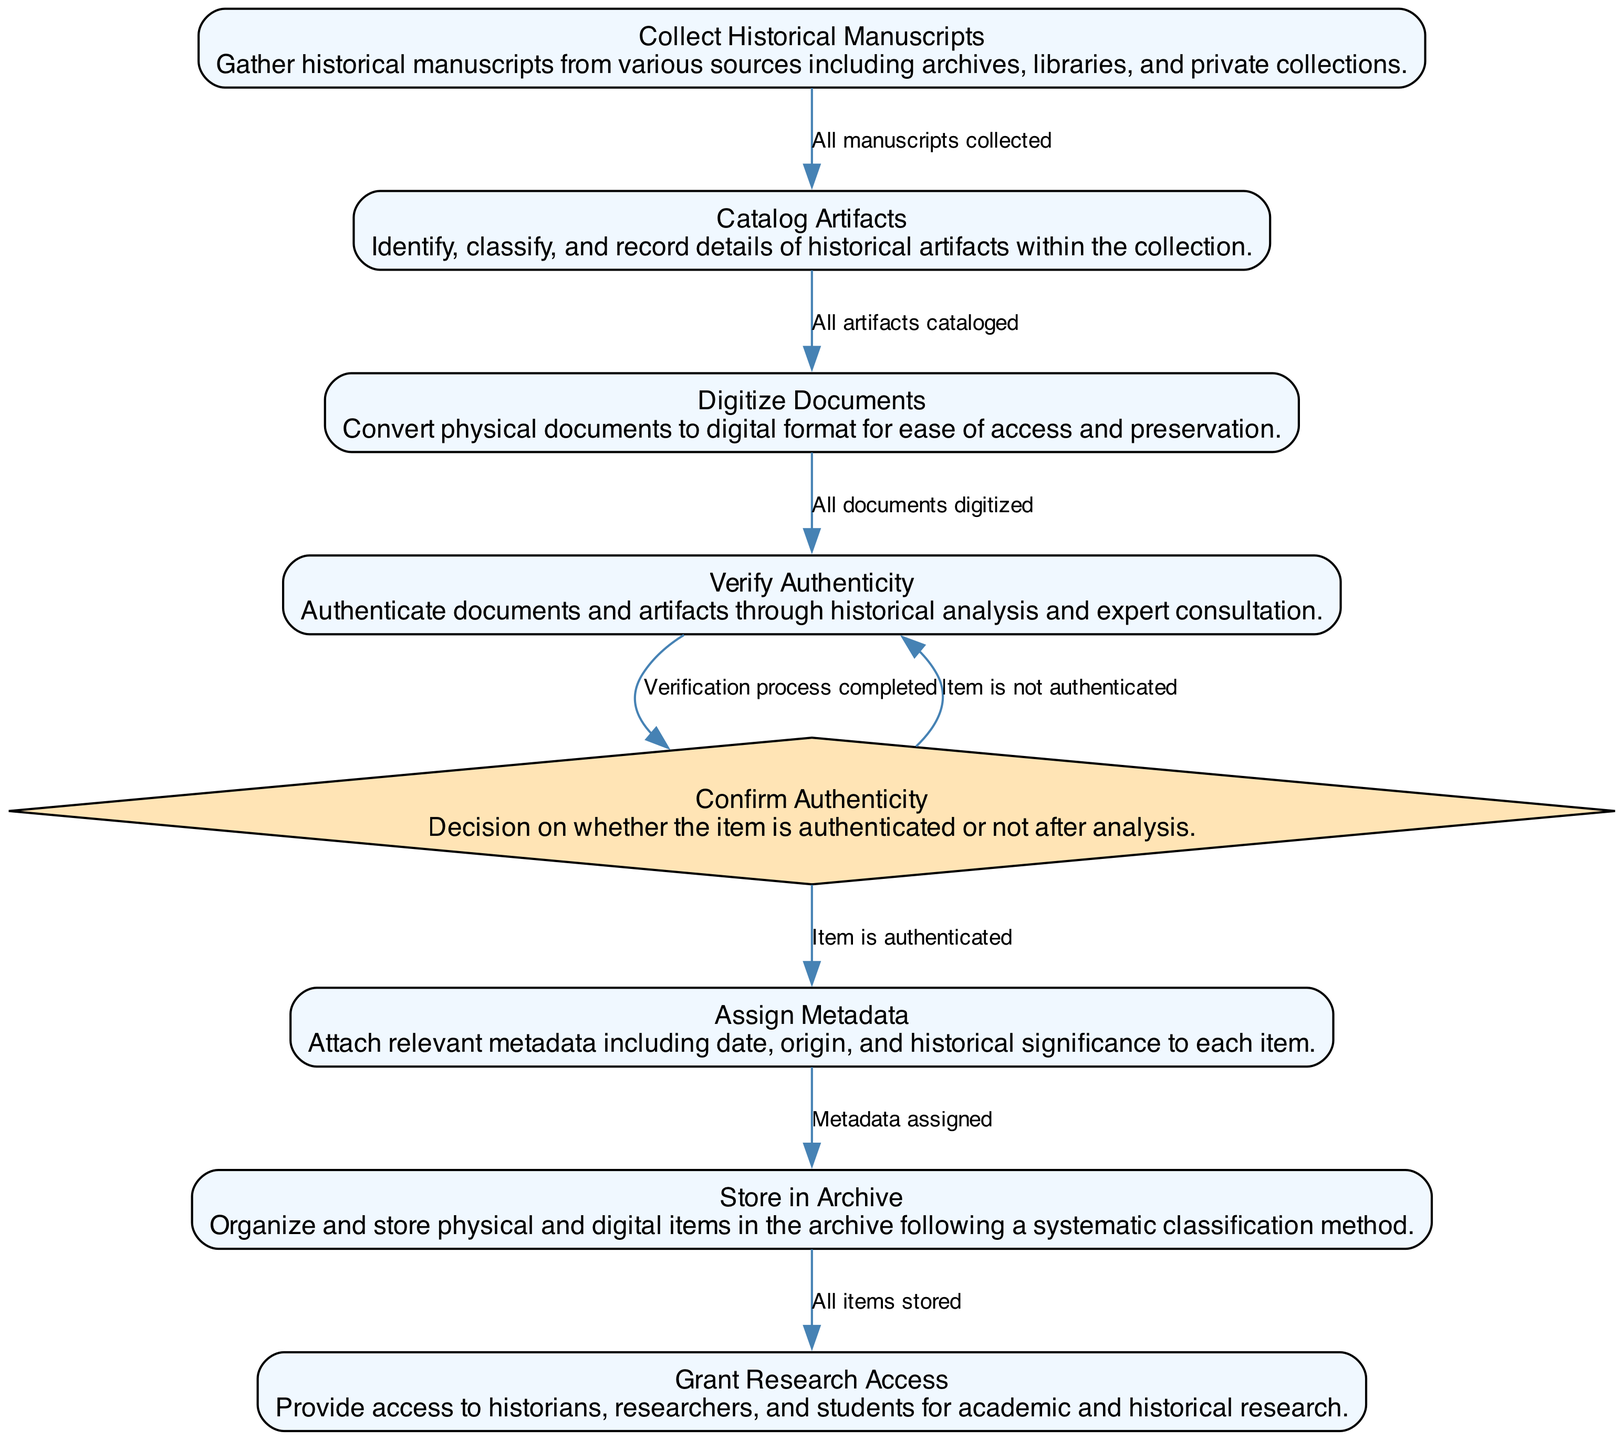What is the first activity in the diagram? The first activity listed in the diagram is "Collect Historical Manuscripts." It is also the starting point for the sequence of actions and feeds into subsequent processes.
Answer: Collect Historical Manuscripts How many activities are present in the diagram? The diagram includes a total of seven activities related to organizing a historical documentation archive. Each activity contributes to the overall process.
Answer: Seven What condition must be met to move from "Catalog Artifacts" to "Digitize Documents"? The transition between "Catalog Artifacts" and "Digitize Documents" requires that all artifacts are cataloged before moving to the next step.
Answer: All artifacts cataloged What happens if an item is not authenticated after the verification process? If an item is not authenticated, the process loops back to the "Verify Authenticity" step, meaning further authentication attempts are necessary before proceeding.
Answer: Loop back to verify authenticity What is the last activity performed in the process? The final activity listed in the diagram is "Grant Research Access," marking the completion of the archival organization process.
Answer: Grant Research Access How many decision points are in the diagram? There is one decision point in the diagram that determines whether an item is authenticated or not after analysis. This decision influences the further steps in the process.
Answer: One What is the condition required to proceed from "Digitize Documents" to "Verify Authenticity"? The prerequisite condition to transition from "Digitize Documents" to "Verify Authenticity" is that all documents have been digitized successfully.
Answer: All documents digitized What action is taken after "Assign Metadata"? After the action of "Assign Metadata," the subsequent action is to "Store in Archive," completing the organization of the physical and digital items.
Answer: Store in Archive Which activity requires expert consultation for historical analysis? The activity that involves expert consultation for historical analysis is "Verify Authenticity," as it includes the validation of documents and artifacts.
Answer: Verify Authenticity 